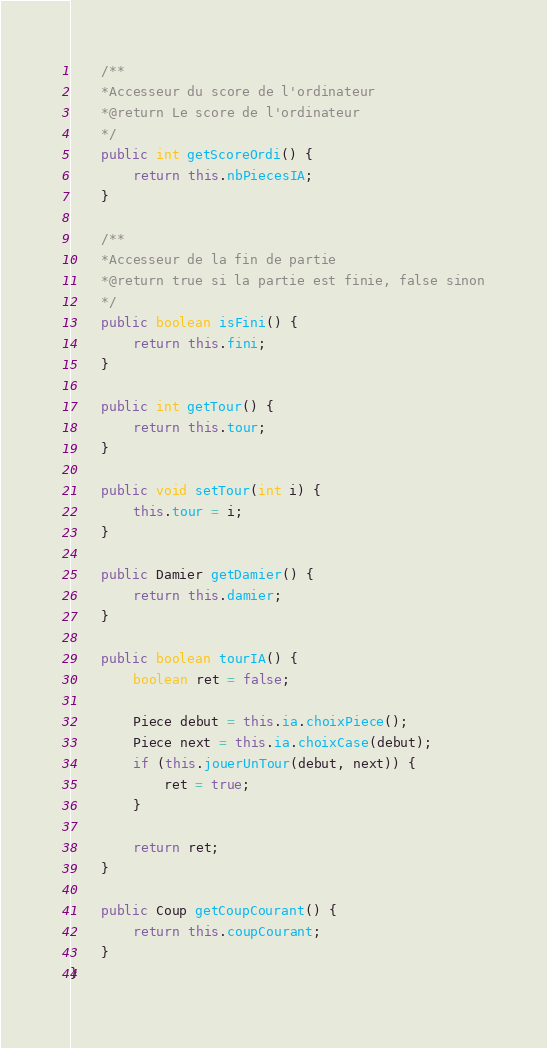Convert code to text. <code><loc_0><loc_0><loc_500><loc_500><_Java_>	/**
	*Accesseur du score de l'ordinateur
	*@return Le score de l'ordinateur
	*/
	public int getScoreOrdi() {
		return this.nbPiecesIA;
	}

	/**
	*Accesseur de la fin de partie
	*@return true si la partie est finie, false sinon
	*/
	public boolean isFini() {
		return this.fini;
	}

	public int getTour() {
		return this.tour;
	}

	public void setTour(int i) {
		this.tour = i;
	}

	public Damier getDamier() {
		return this.damier;
	}

	public boolean tourIA() {
		boolean ret = false;

		Piece debut = this.ia.choixPiece();
		Piece next = this.ia.choixCase(debut);
		if (this.jouerUnTour(debut, next)) {
			ret = true;
		}

		return ret;
	}

	public Coup getCoupCourant() {
		return this.coupCourant;
	}
}
</code> 